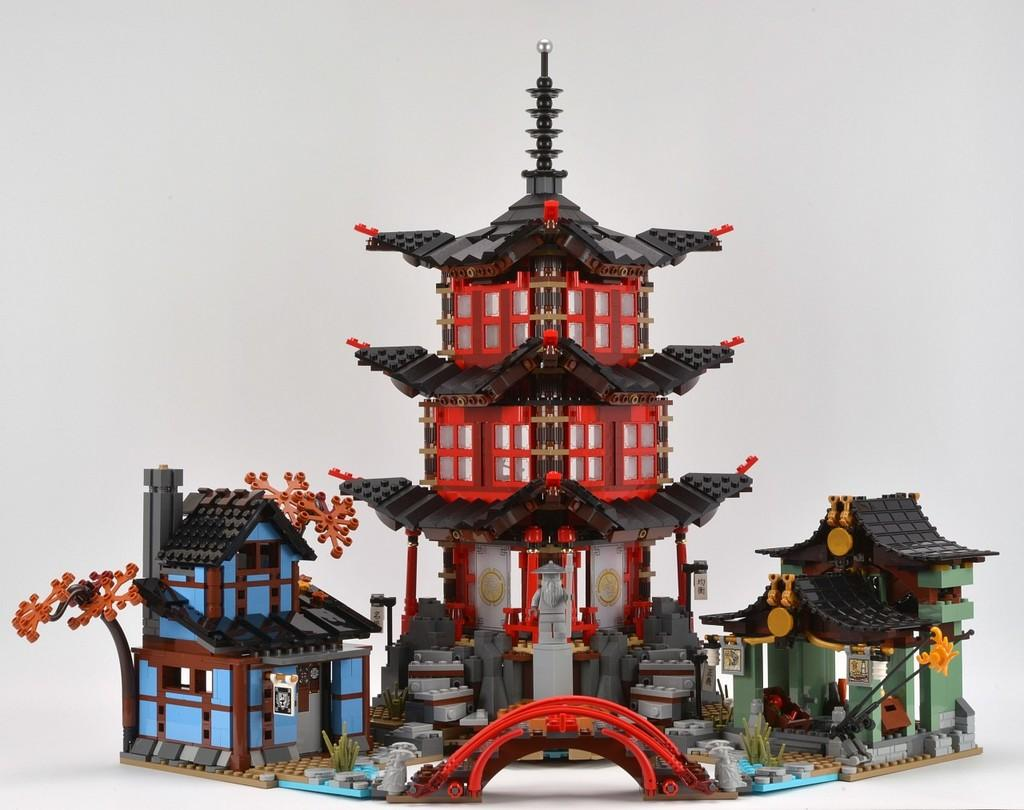What type of objects are in the image? There are toy houses in the image. What color is the background of the image? The background of the image is white. What type of meat can be seen hanging in the yard in the image? There is no yard or meat present in the image; it features toy houses with a white background. 